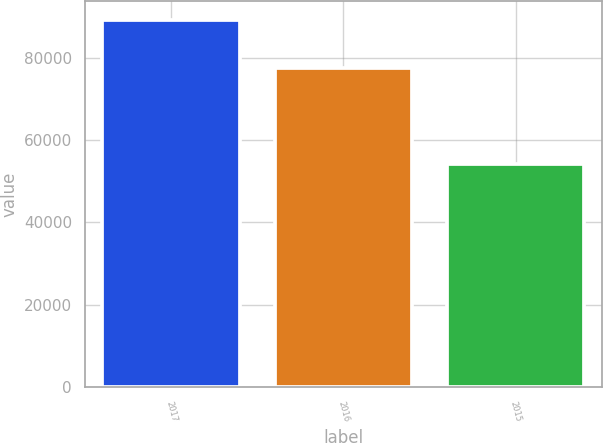Convert chart. <chart><loc_0><loc_0><loc_500><loc_500><bar_chart><fcel>2017<fcel>2016<fcel>2015<nl><fcel>89226<fcel>77445<fcel>54219<nl></chart> 